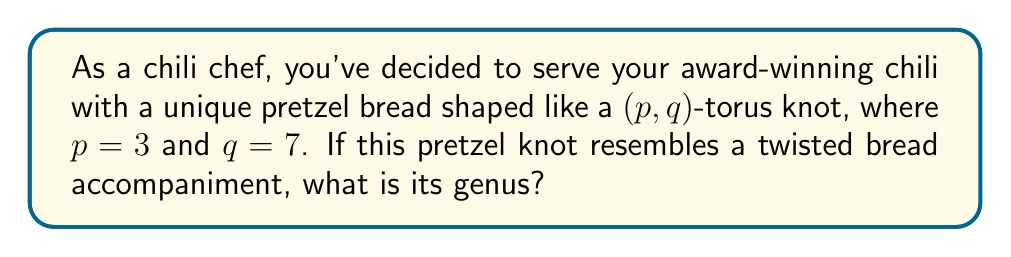Can you answer this question? To determine the genus of a $(p,q)$-torus knot, we can follow these steps:

1. Recall the formula for the genus of a $(p,q)$-torus knot:
   $$g = \frac{(p-1)(q-1)}{2}$$

2. In this case, we have $p=3$ and $q=7$. Let's substitute these values:
   $$g = \frac{(3-1)(7-1)}{2}$$

3. Simplify the numerator:
   $$g = \frac{2 \cdot 6}{2}$$

4. Multiply:
   $$g = \frac{12}{2}$$

5. Simplify:
   $$g = 6$$

Therefore, the genus of the $(3,7)$-torus knot pretzel bread is 6.
Answer: 6 